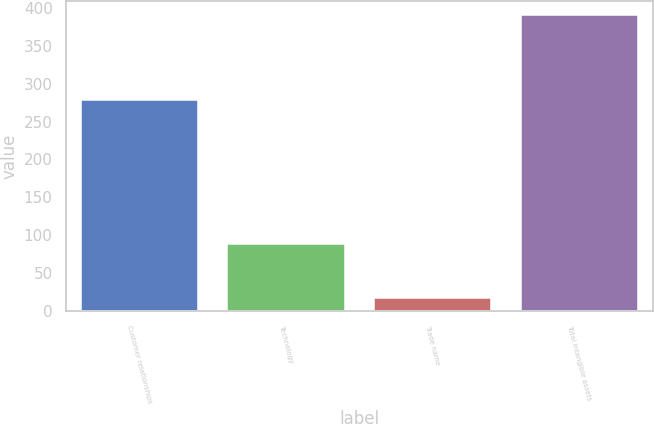<chart> <loc_0><loc_0><loc_500><loc_500><bar_chart><fcel>Customer relationships<fcel>Technology<fcel>Trade name<fcel>Total intangible assets<nl><fcel>279<fcel>89<fcel>17<fcel>390<nl></chart> 